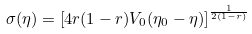<formula> <loc_0><loc_0><loc_500><loc_500>\sigma ( \eta ) = \left [ 4 r ( 1 - r ) V _ { 0 } ( \eta _ { 0 } - \eta ) \right ] ^ { \frac { 1 } { 2 ( 1 - r ) } }</formula> 